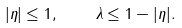Convert formula to latex. <formula><loc_0><loc_0><loc_500><loc_500>| \eta | \leq 1 , \quad \lambda \leq 1 - | \eta | .</formula> 